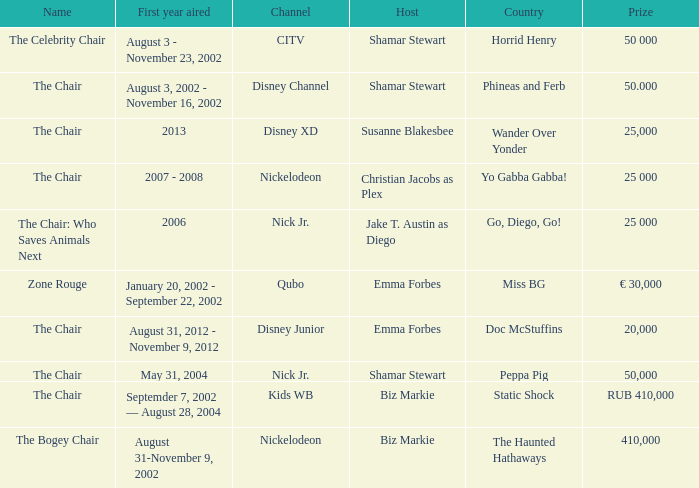What was the host of Horrid Henry? Shamar Stewart. 